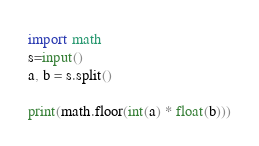Convert code to text. <code><loc_0><loc_0><loc_500><loc_500><_Python_>import math
s=input()
a, b = s.split()

print(math.floor(int(a) * float(b)))</code> 